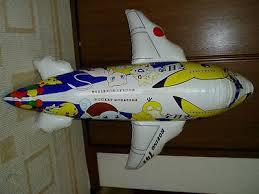Is there an aeroplane in the image? Yes, there is a toy airplane in the image, decorated in bright colors and cartoon designs, likely appealing to children. 